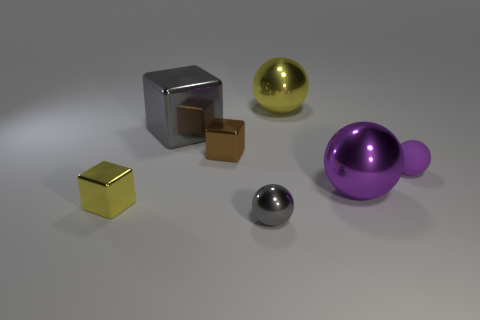What could be the significance of the arrangement of these objects in the space? The deliberate arrangement might represent the concept of balance and order, with varying sizes, colors, and positions potentially signifying the diversity and interconnectedness of elements within a system or narrative. Could there be a symbolic meaning behind the different shapes? Yes, the shapes could symbolize a range of concepts: the cubes might represent stability and tradition, the sphere could suggest unity and completeness, and the variance in size could speak to the idea of growth or hierarchy among similar entities. 